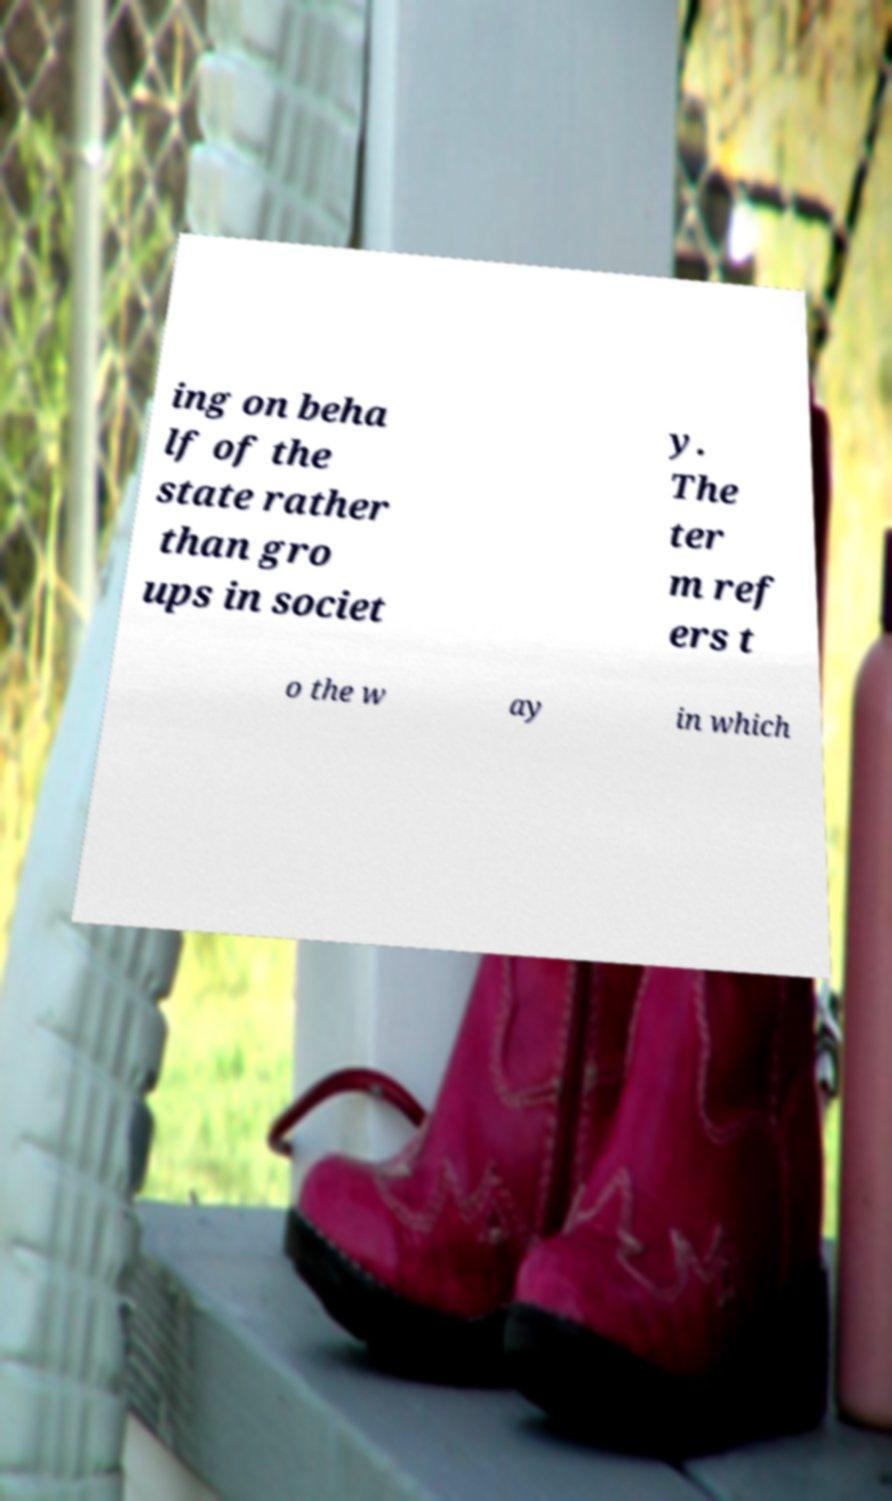Could you extract and type out the text from this image? ing on beha lf of the state rather than gro ups in societ y. The ter m ref ers t o the w ay in which 